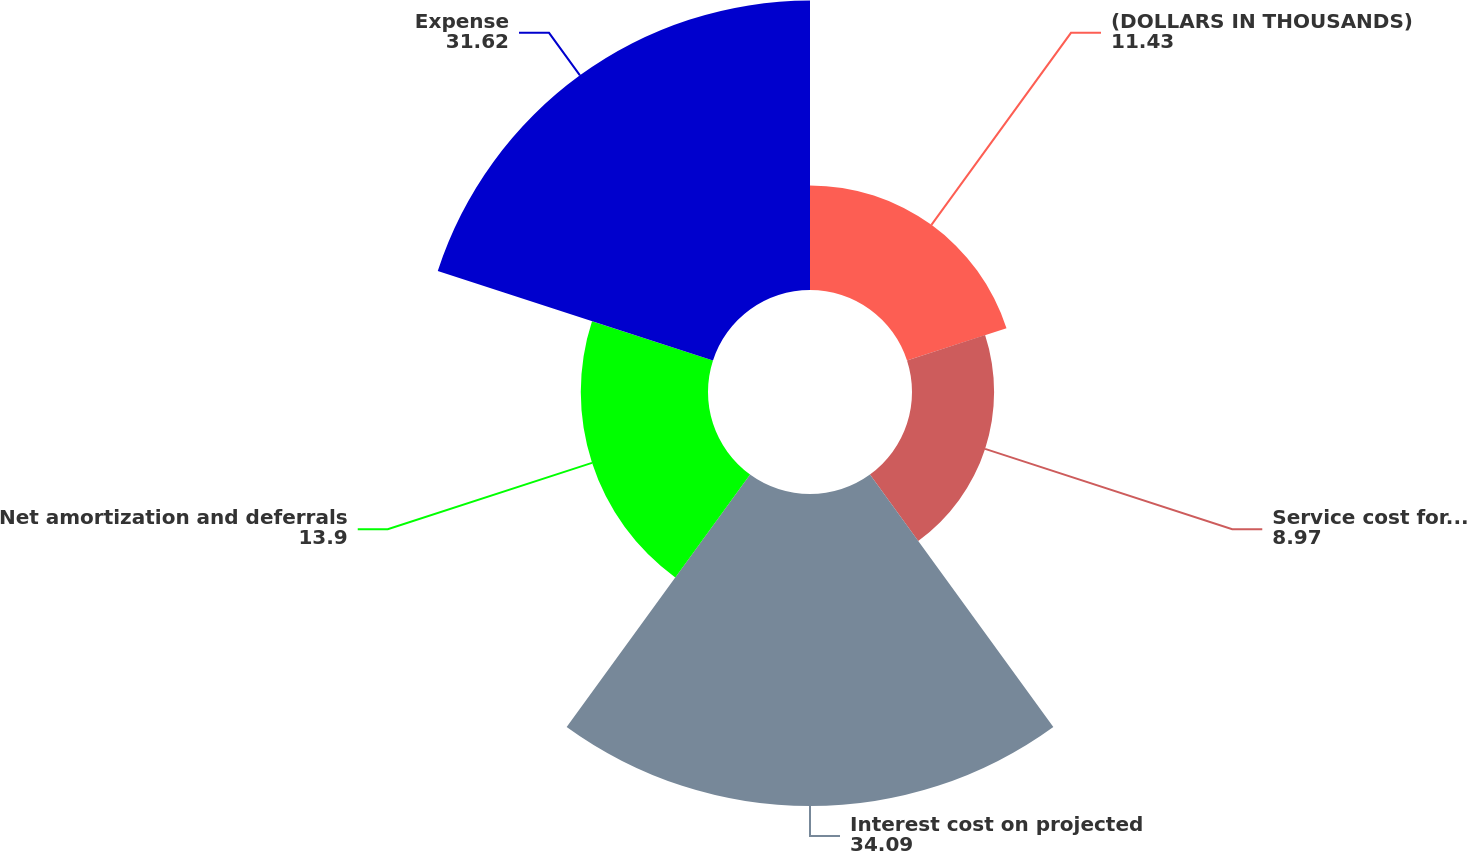Convert chart to OTSL. <chart><loc_0><loc_0><loc_500><loc_500><pie_chart><fcel>(DOLLARS IN THOUSANDS)<fcel>Service cost for benefits<fcel>Interest cost on projected<fcel>Net amortization and deferrals<fcel>Expense<nl><fcel>11.43%<fcel>8.97%<fcel>34.09%<fcel>13.9%<fcel>31.62%<nl></chart> 